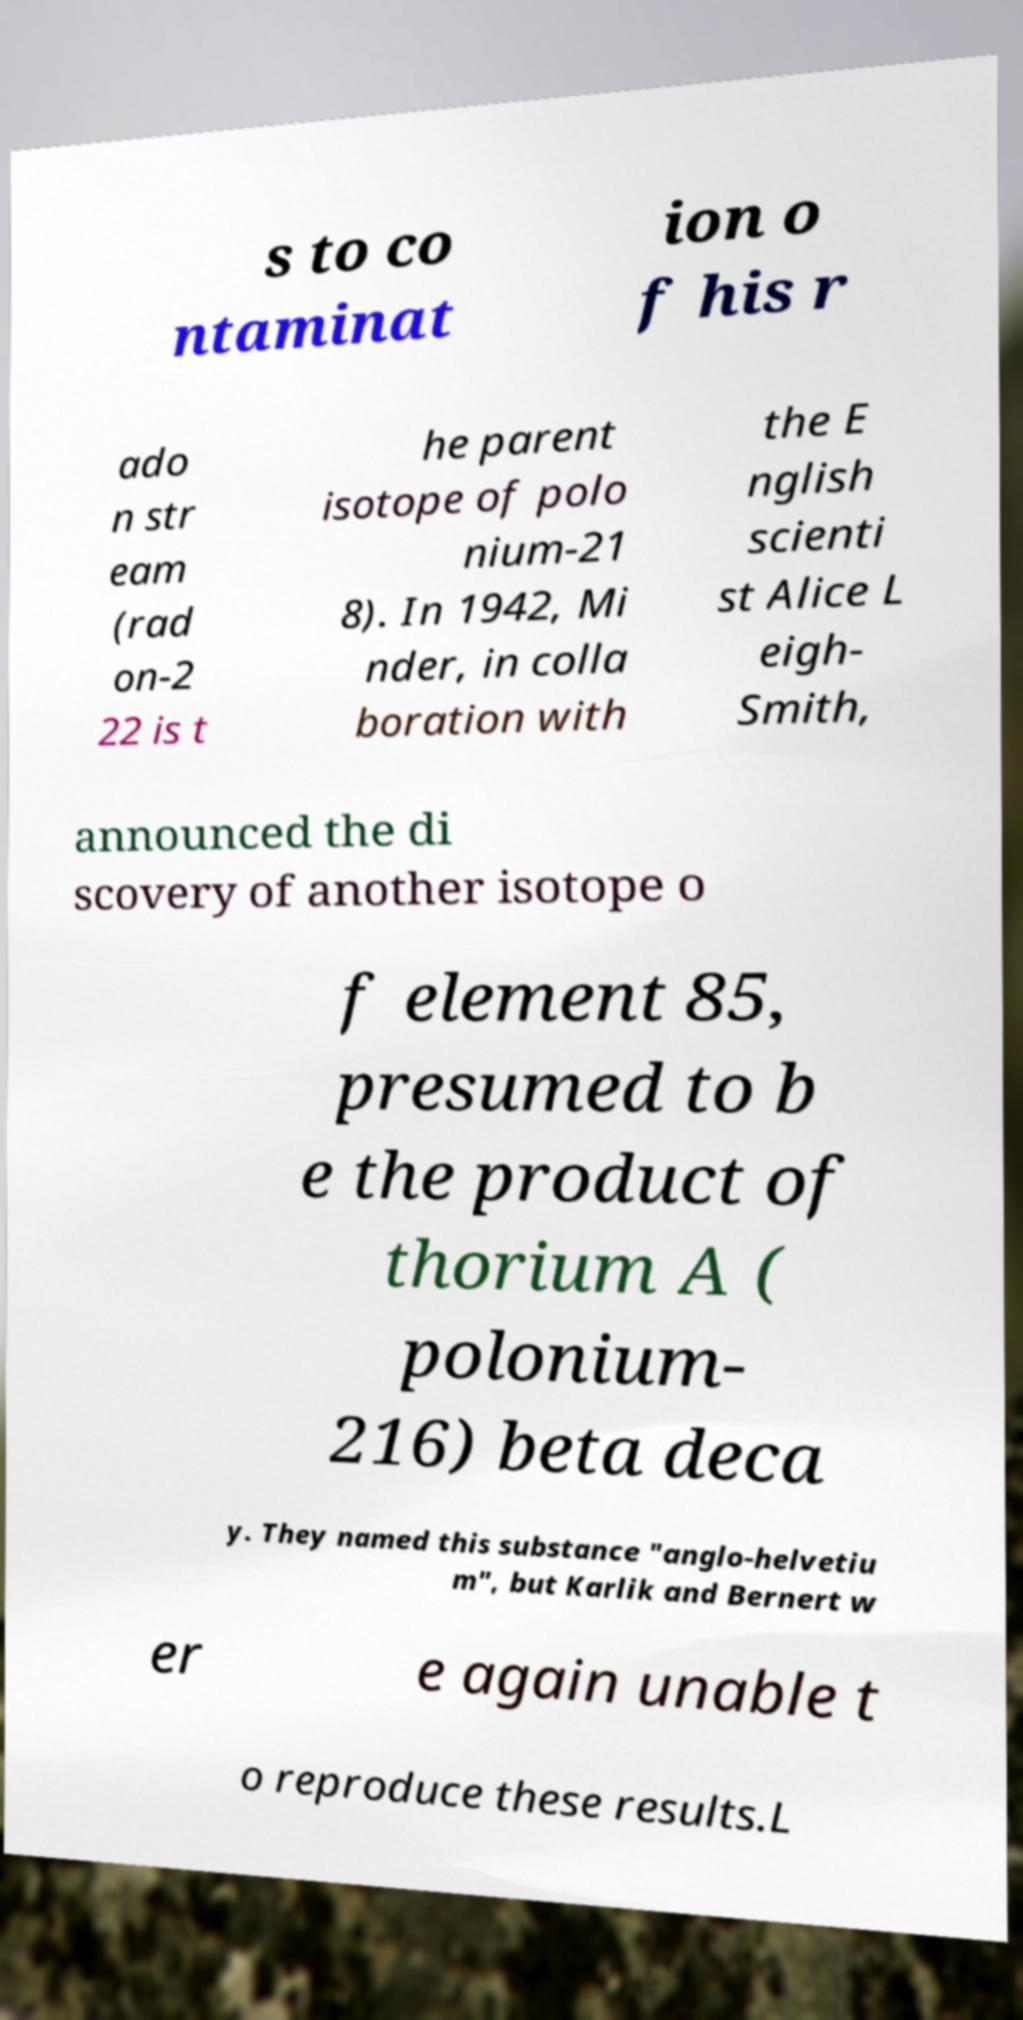Could you assist in decoding the text presented in this image and type it out clearly? s to co ntaminat ion o f his r ado n str eam (rad on-2 22 is t he parent isotope of polo nium-21 8). In 1942, Mi nder, in colla boration with the E nglish scienti st Alice L eigh- Smith, announced the di scovery of another isotope o f element 85, presumed to b e the product of thorium A ( polonium- 216) beta deca y. They named this substance "anglo-helvetiu m", but Karlik and Bernert w er e again unable t o reproduce these results.L 